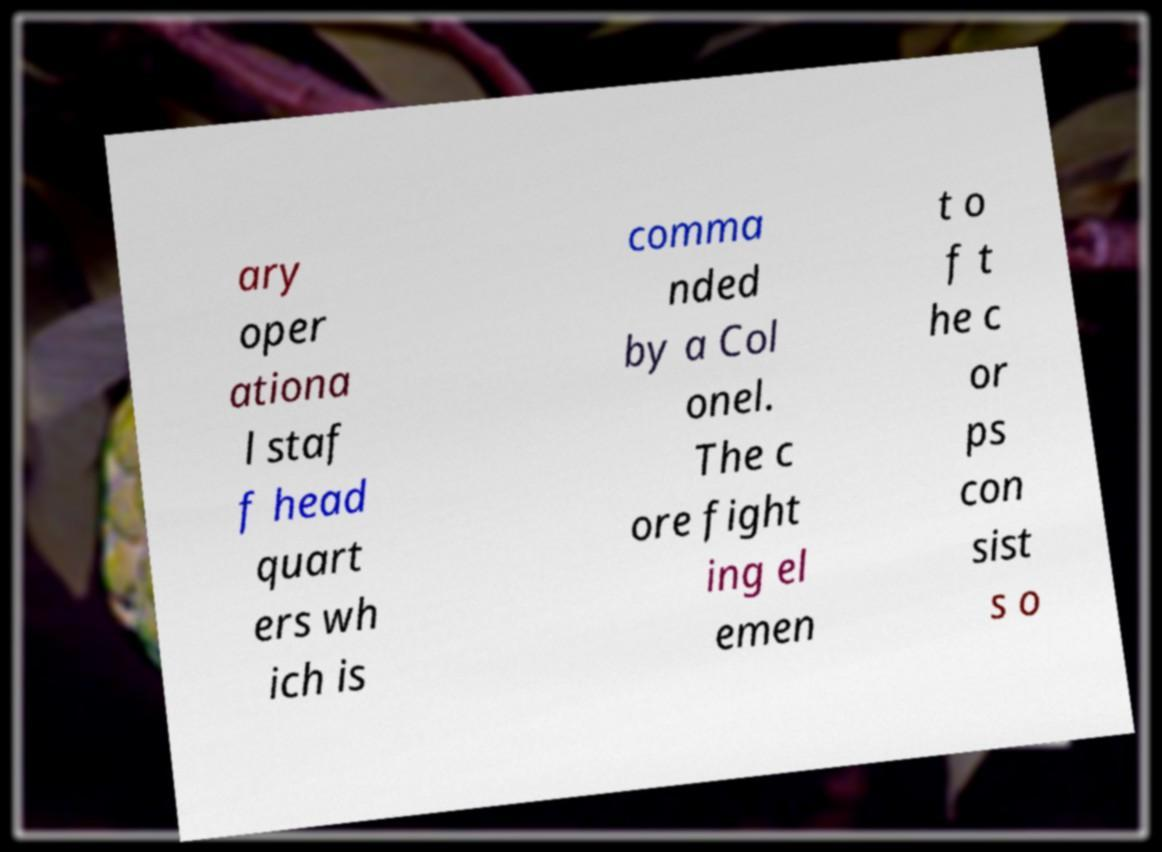There's text embedded in this image that I need extracted. Can you transcribe it verbatim? ary oper ationa l staf f head quart ers wh ich is comma nded by a Col onel. The c ore fight ing el emen t o f t he c or ps con sist s o 